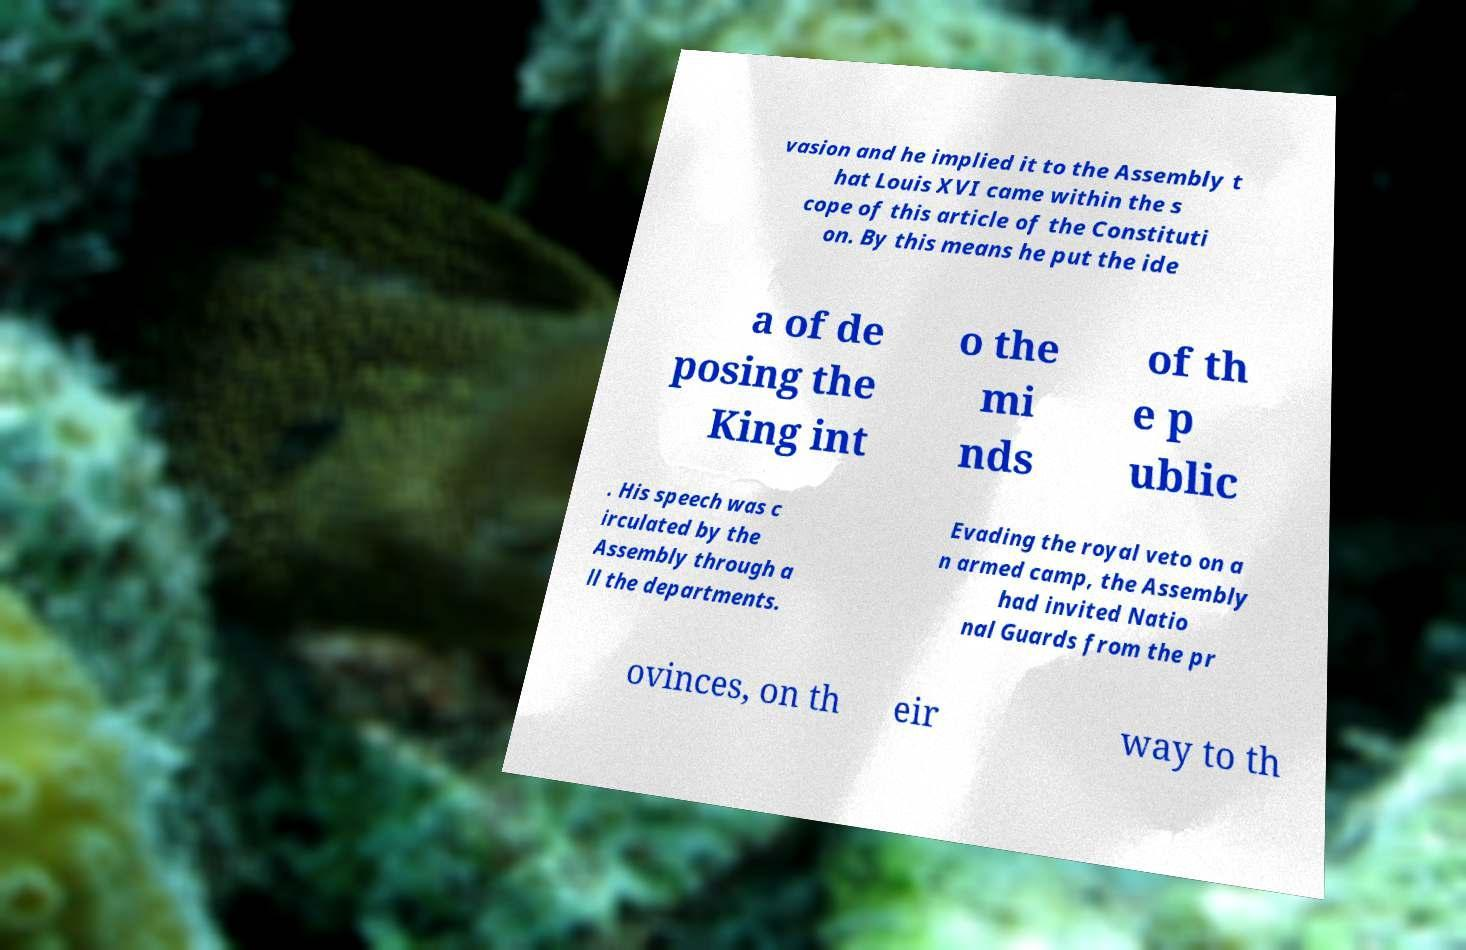Please identify and transcribe the text found in this image. vasion and he implied it to the Assembly t hat Louis XVI came within the s cope of this article of the Constituti on. By this means he put the ide a of de posing the King int o the mi nds of th e p ublic . His speech was c irculated by the Assembly through a ll the departments. Evading the royal veto on a n armed camp, the Assembly had invited Natio nal Guards from the pr ovinces, on th eir way to th 